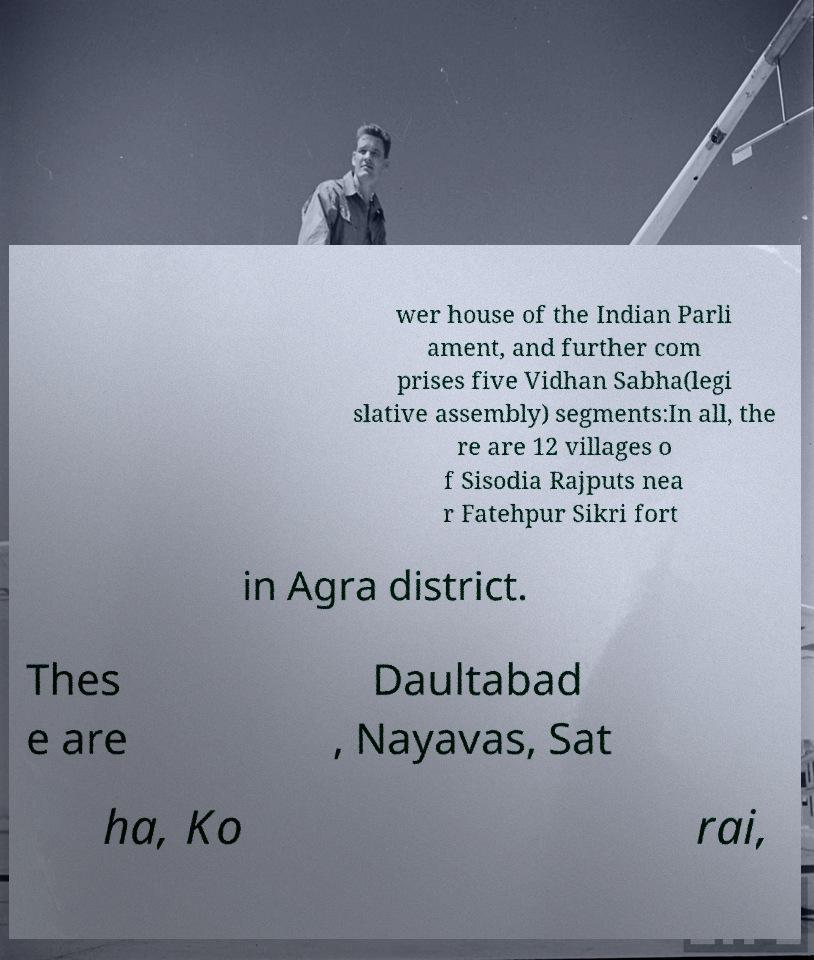Please identify and transcribe the text found in this image. wer house of the Indian Parli ament, and further com prises five Vidhan Sabha(legi slative assembly) segments:In all, the re are 12 villages o f Sisodia Rajputs nea r Fatehpur Sikri fort in Agra district. Thes e are Daultabad , Nayavas, Sat ha, Ko rai, 